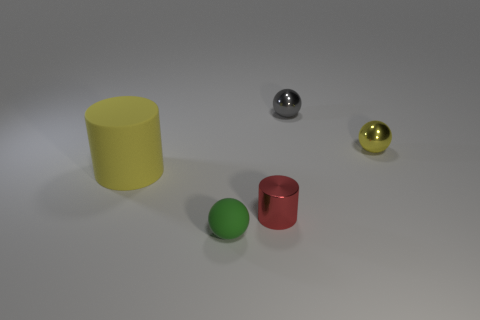Is the color of the large cylinder the same as the ball to the right of the gray metallic sphere?
Provide a succinct answer. Yes. What size is the rubber object that is behind the matte object in front of the object on the left side of the tiny green sphere?
Give a very brief answer. Large. What number of other things are there of the same shape as the small yellow thing?
Your answer should be compact. 2. Is the shape of the metallic object in front of the yellow matte object the same as the large rubber thing that is on the left side of the small red cylinder?
Give a very brief answer. Yes. What number of blocks are small red things or tiny yellow metallic things?
Ensure brevity in your answer.  0. What material is the yellow object on the right side of the cylinder that is to the right of the sphere in front of the big thing made of?
Ensure brevity in your answer.  Metal. What number of other things are there of the same size as the yellow metallic ball?
Keep it short and to the point. 3. Is the number of red cylinders right of the yellow matte cylinder greater than the number of tiny cyan blocks?
Your answer should be very brief. Yes. Are there any big metallic cylinders that have the same color as the rubber sphere?
Provide a short and direct response. No. There is a rubber thing that is the same size as the red cylinder; what color is it?
Ensure brevity in your answer.  Green. 